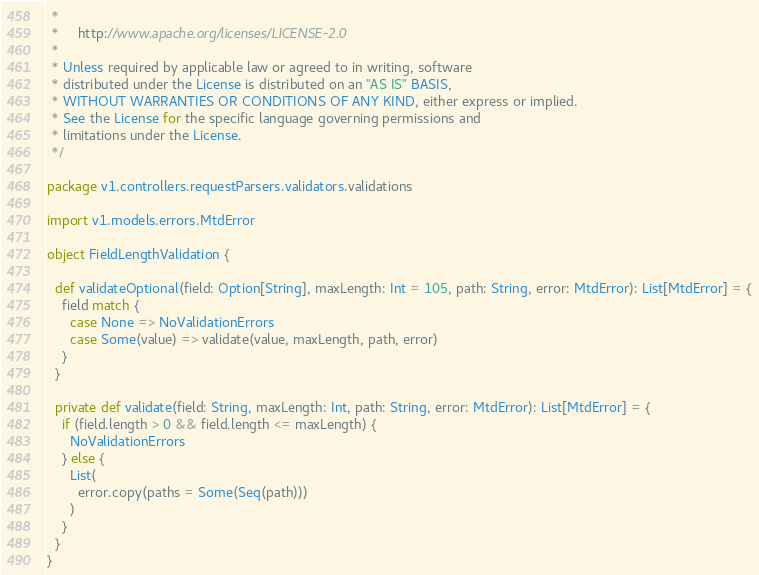<code> <loc_0><loc_0><loc_500><loc_500><_Scala_> *
 *     http://www.apache.org/licenses/LICENSE-2.0
 *
 * Unless required by applicable law or agreed to in writing, software
 * distributed under the License is distributed on an "AS IS" BASIS,
 * WITHOUT WARRANTIES OR CONDITIONS OF ANY KIND, either express or implied.
 * See the License for the specific language governing permissions and
 * limitations under the License.
 */

package v1.controllers.requestParsers.validators.validations

import v1.models.errors.MtdError

object FieldLengthValidation {

  def validateOptional(field: Option[String], maxLength: Int = 105, path: String, error: MtdError): List[MtdError] = {
    field match {
      case None => NoValidationErrors
      case Some(value) => validate(value, maxLength, path, error)
    }
  }

  private def validate(field: String, maxLength: Int, path: String, error: MtdError): List[MtdError] = {
    if (field.length > 0 && field.length <= maxLength) {
      NoValidationErrors
    } else {
      List(
        error.copy(paths = Some(Seq(path)))
      )
    }
  }
}
</code> 